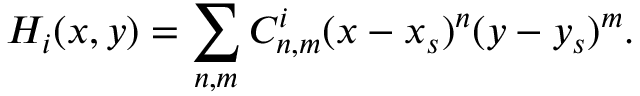<formula> <loc_0><loc_0><loc_500><loc_500>H _ { i } ( x , y ) = \sum _ { n , m } C _ { n , m } ^ { i } ( x - x _ { s } ) ^ { n } ( y - y _ { s } ) ^ { m } .</formula> 